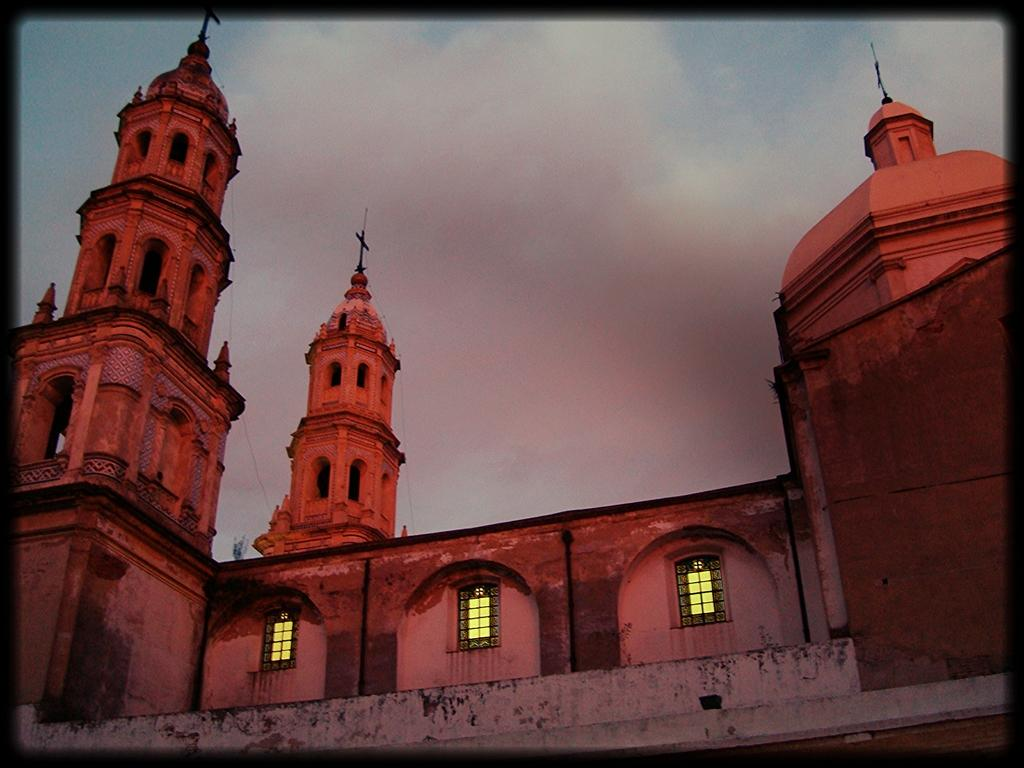What is the main subject in the center of the image? There is a building in the center of the image. What can be seen in the background of the image? There is sky visible in the background of the image. What is present in the sky? There are clouds in the sky. What type of balance is being demonstrated by the tank in the image? There is no tank present in the image, so it is not possible to determine if any balance is being demonstrated. 